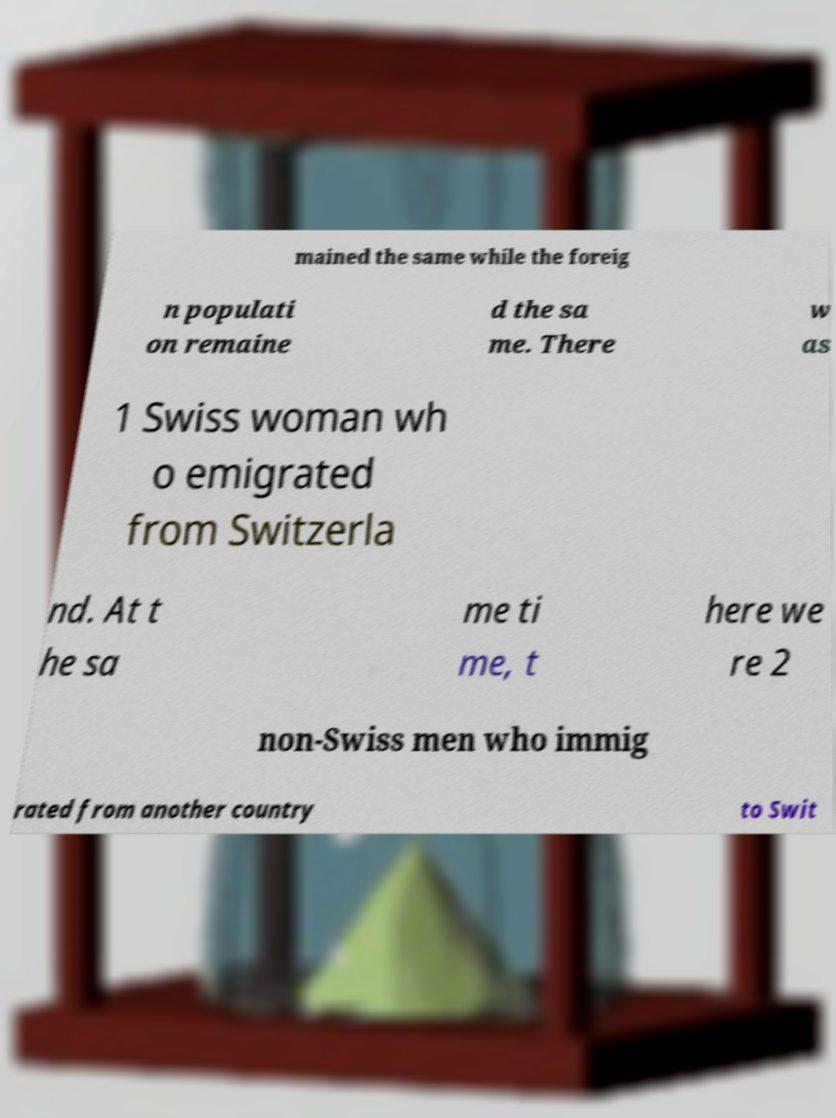Please identify and transcribe the text found in this image. mained the same while the foreig n populati on remaine d the sa me. There w as 1 Swiss woman wh o emigrated from Switzerla nd. At t he sa me ti me, t here we re 2 non-Swiss men who immig rated from another country to Swit 